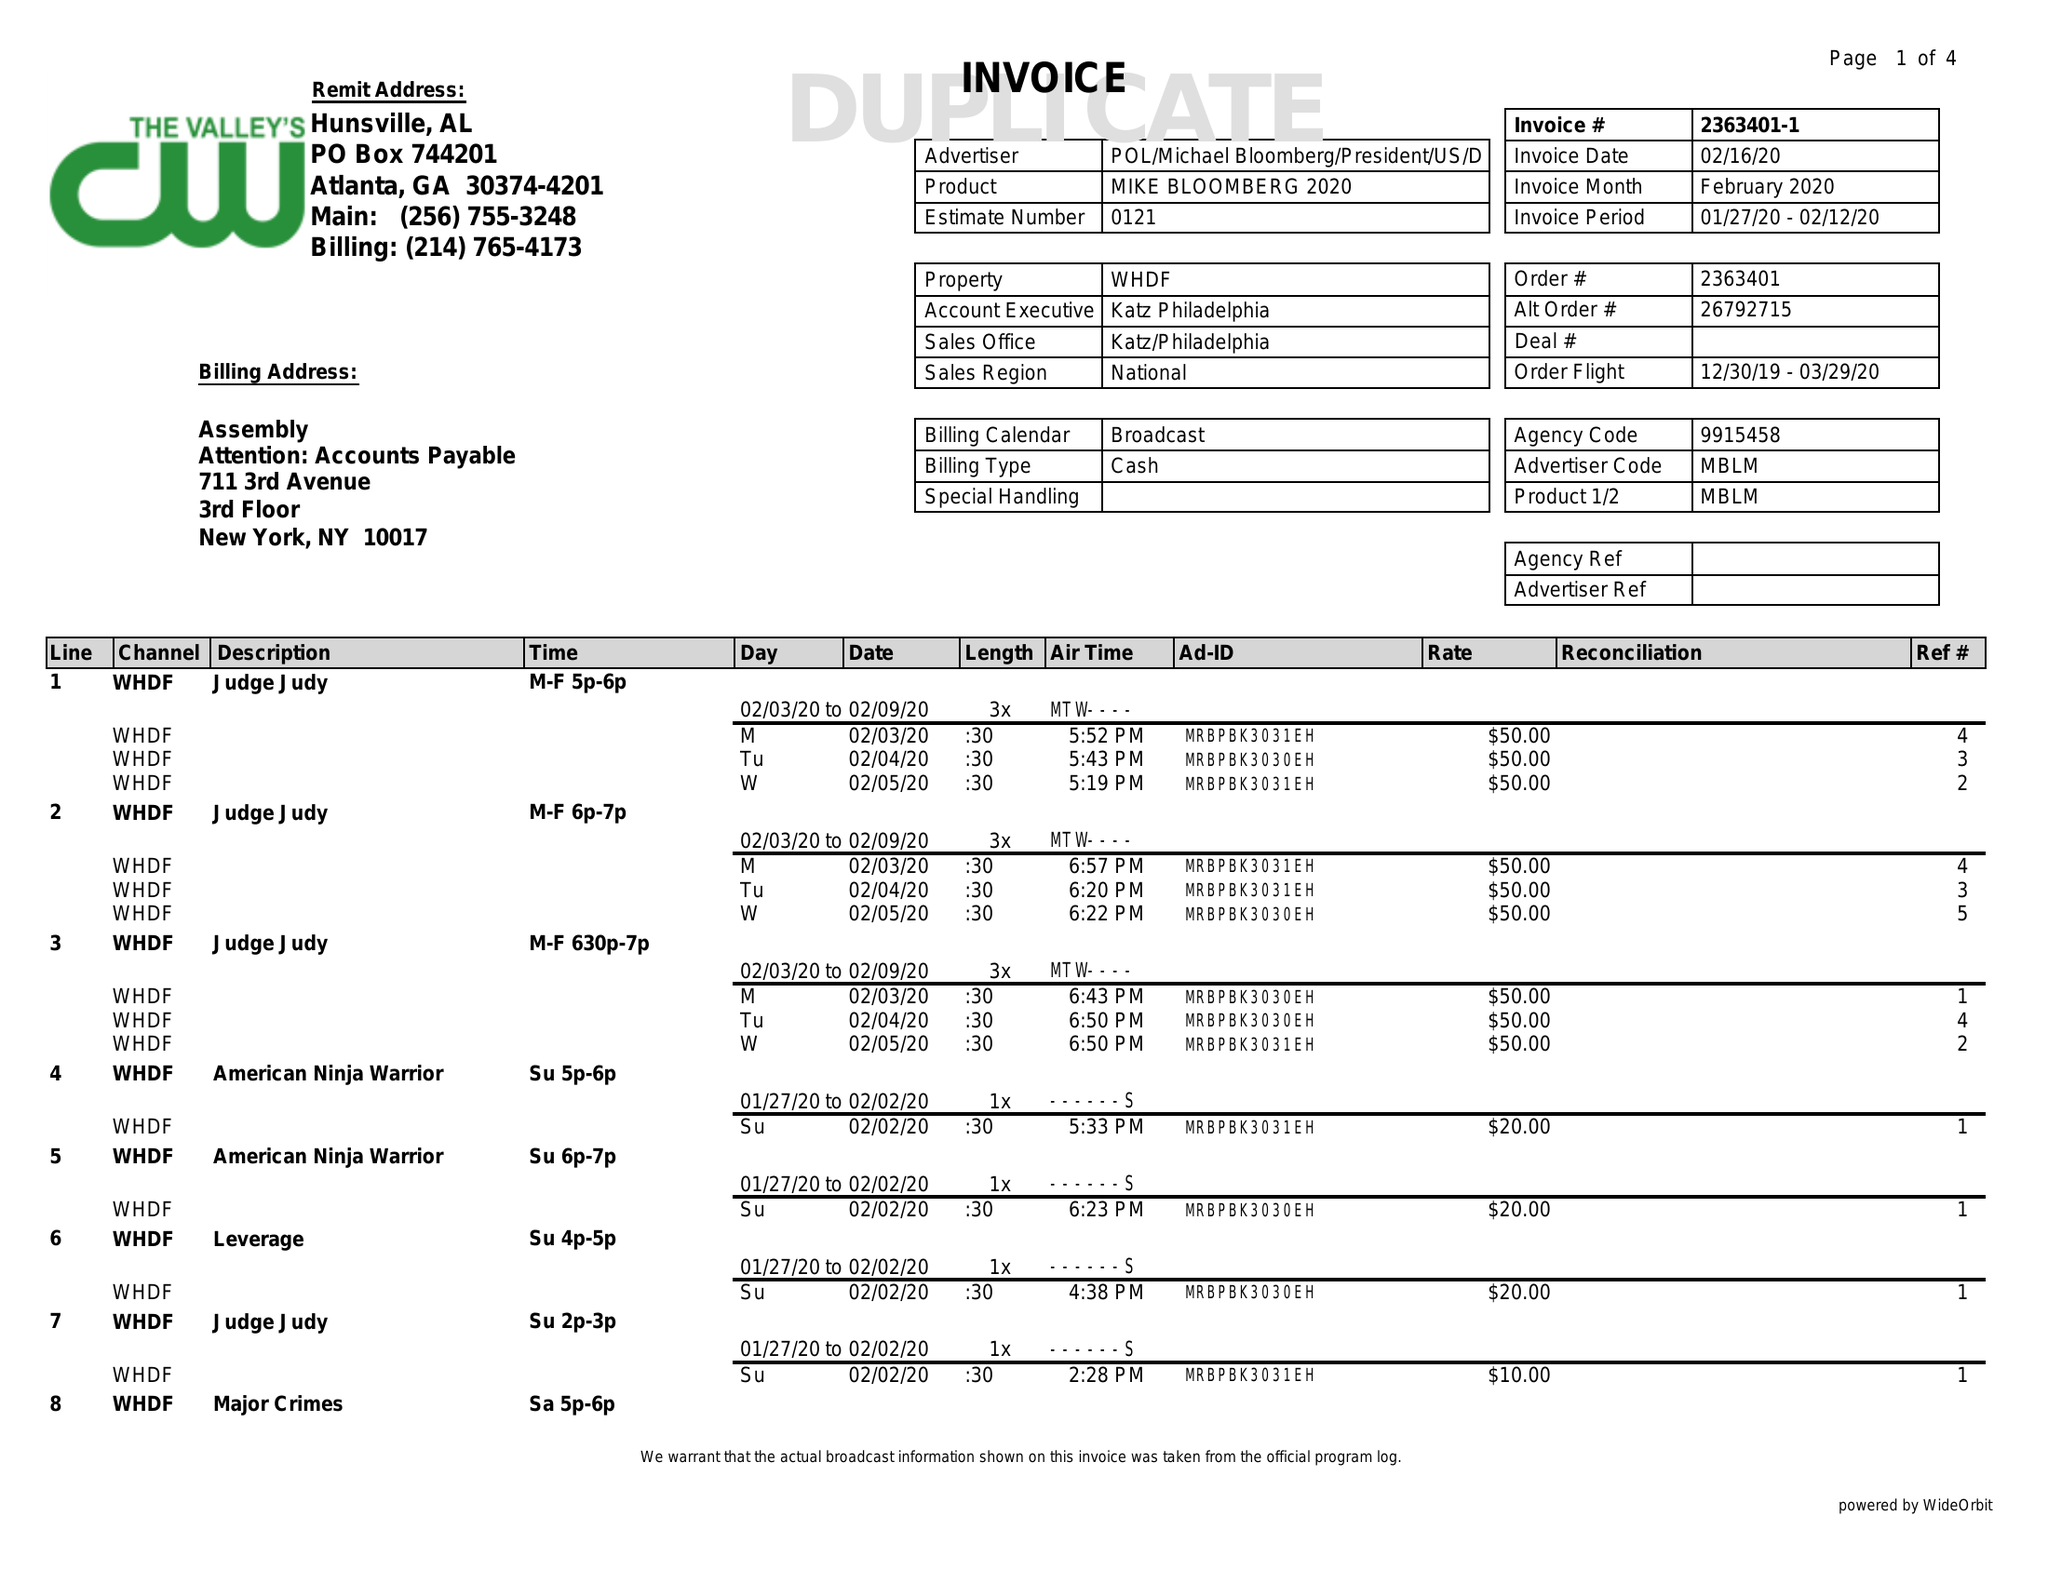What is the value for the contract_num?
Answer the question using a single word or phrase. 2363401 